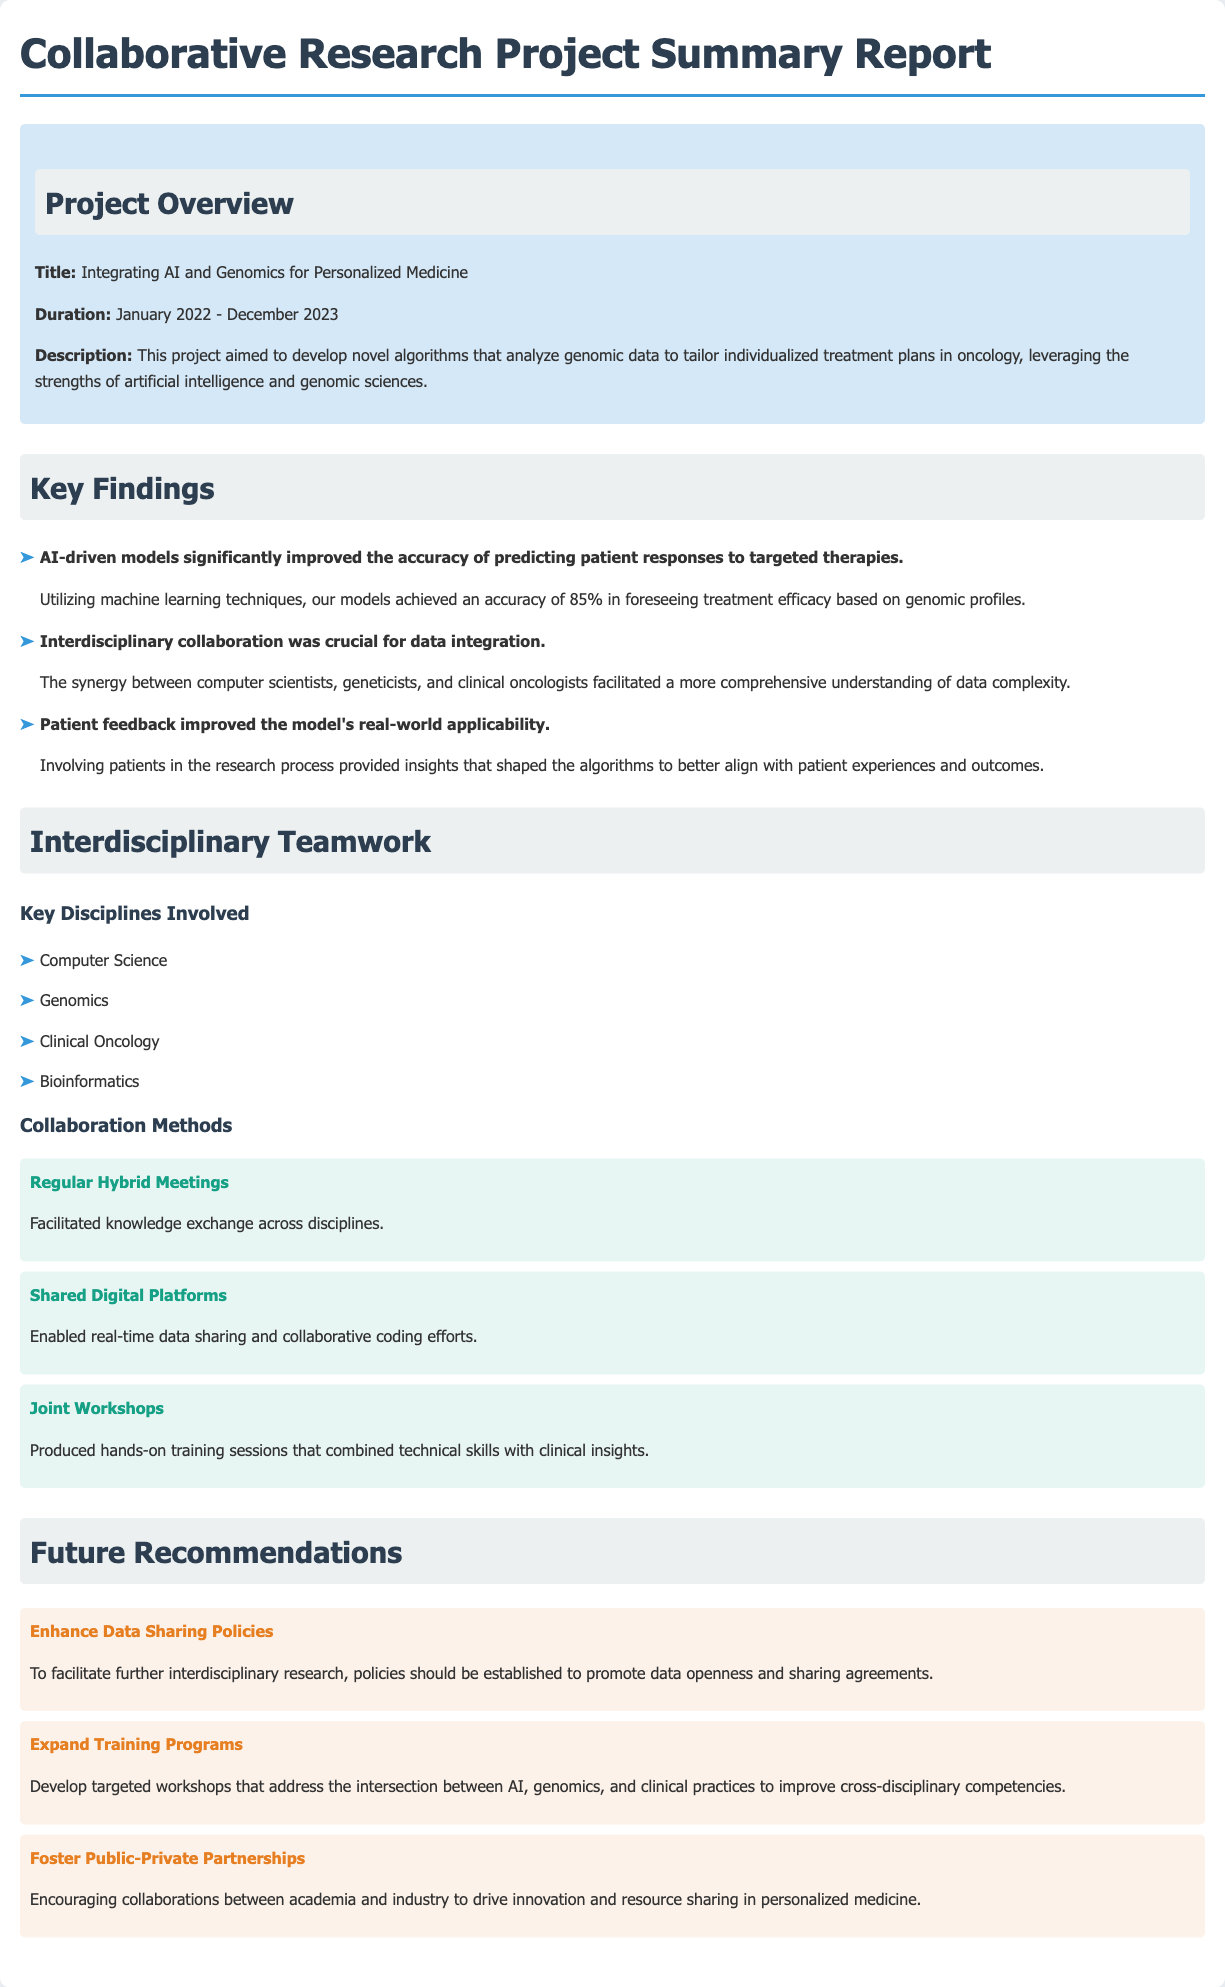What is the title of the project? The title is found in the project overview section of the document.
Answer: Integrating AI and Genomics for Personalized Medicine What is the duration of the project? The duration is specified in the project overview section.
Answer: January 2022 - December 2023 What was the accuracy percentage of predicting patient responses achieved by AI-driven models? The accuracy percentage is mentioned in the key findings section under AI-driven models.
Answer: 85% Which disciplines were key to the interdisciplinary teamwork? Key disciplines are listed in the interdisciplinary teamwork section of the document.
Answer: Computer Science, Genomics, Clinical Oncology, Bioinformatics What collaboration method involved knowledge exchange across disciplines? The collaboration method is detailed in the interdisciplinary teamwork section.
Answer: Regular Hybrid Meetings What is one of the future recommendations regarding data? Future recommendations are provided at the end of the document; one highlights data sharing.
Answer: Enhance Data Sharing Policies What is one way to improve cross-disciplinary competencies? The method to improve competencies is found in the future recommendations section of the document.
Answer: Expand Training Programs What type of partnerships are recommended to foster collaboration? The recommendation for partnerships is listed under future recommendations.
Answer: Public-Private Partnerships 